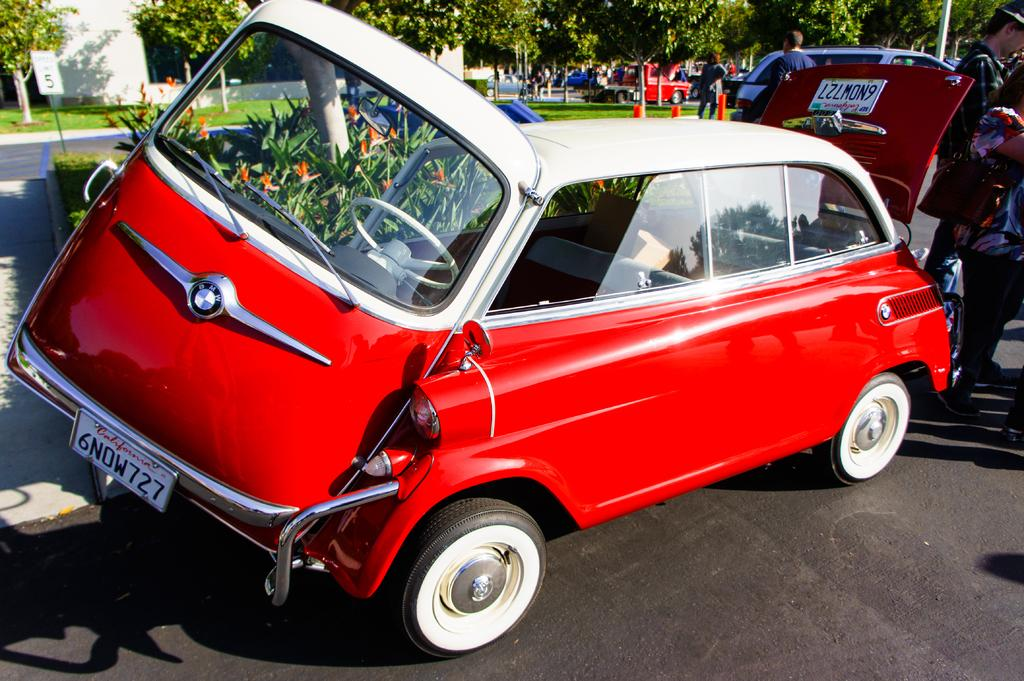What can be seen on the road in the image? There are vehicles on the road in the image. What else is present in the image besides vehicles? There are people standing in the image and trees. Can any structures be identified in the image? Yes, there is at least one building present in the image. Where is the basin located in the image? There is no basin present in the image. What type of arch can be seen in the image? There is no arch present in the image. 